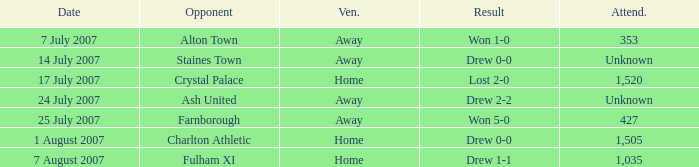Name the venue for staines town Away. 